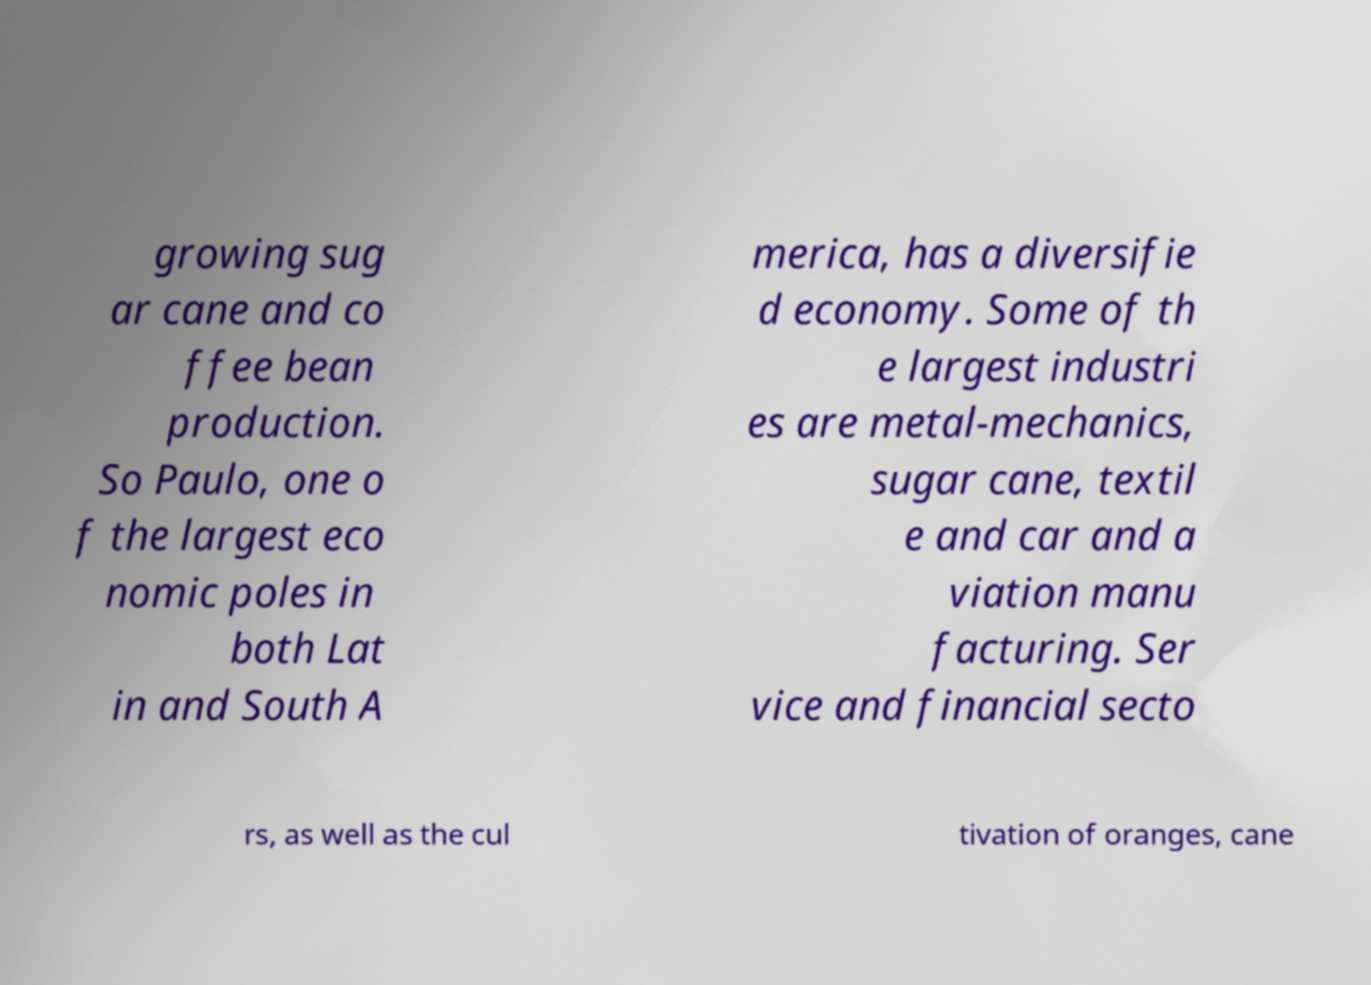Could you assist in decoding the text presented in this image and type it out clearly? growing sug ar cane and co ffee bean production. So Paulo, one o f the largest eco nomic poles in both Lat in and South A merica, has a diversifie d economy. Some of th e largest industri es are metal-mechanics, sugar cane, textil e and car and a viation manu facturing. Ser vice and financial secto rs, as well as the cul tivation of oranges, cane 